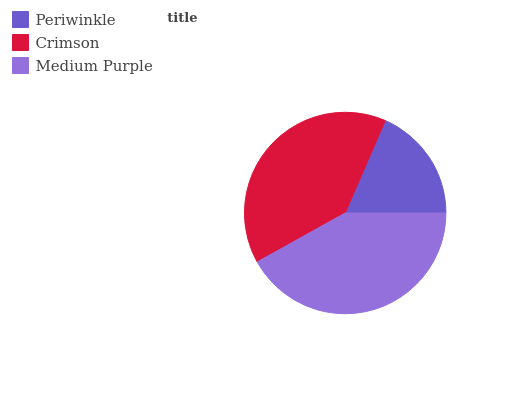Is Periwinkle the minimum?
Answer yes or no. Yes. Is Medium Purple the maximum?
Answer yes or no. Yes. Is Crimson the minimum?
Answer yes or no. No. Is Crimson the maximum?
Answer yes or no. No. Is Crimson greater than Periwinkle?
Answer yes or no. Yes. Is Periwinkle less than Crimson?
Answer yes or no. Yes. Is Periwinkle greater than Crimson?
Answer yes or no. No. Is Crimson less than Periwinkle?
Answer yes or no. No. Is Crimson the high median?
Answer yes or no. Yes. Is Crimson the low median?
Answer yes or no. Yes. Is Periwinkle the high median?
Answer yes or no. No. Is Periwinkle the low median?
Answer yes or no. No. 